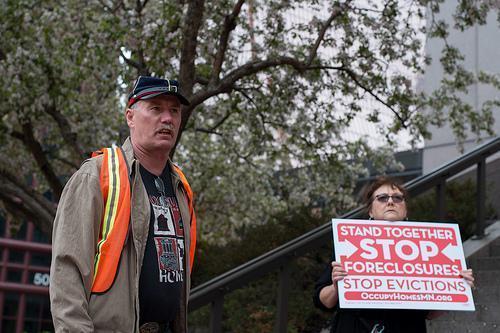How many people?
Give a very brief answer. 2. How many signs?
Give a very brief answer. 1. 